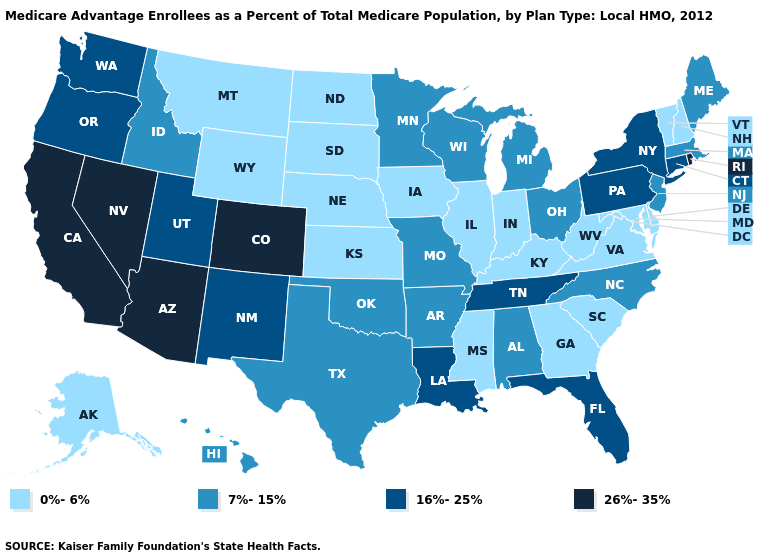What is the value of Maryland?
Be succinct. 0%-6%. What is the value of Nebraska?
Concise answer only. 0%-6%. What is the highest value in the USA?
Write a very short answer. 26%-35%. Name the states that have a value in the range 0%-6%?
Short answer required. Alaska, Delaware, Georgia, Iowa, Illinois, Indiana, Kansas, Kentucky, Maryland, Mississippi, Montana, North Dakota, Nebraska, New Hampshire, South Carolina, South Dakota, Virginia, Vermont, West Virginia, Wyoming. What is the lowest value in the USA?
Give a very brief answer. 0%-6%. Is the legend a continuous bar?
Be succinct. No. Name the states that have a value in the range 7%-15%?
Be succinct. Alabama, Arkansas, Hawaii, Idaho, Massachusetts, Maine, Michigan, Minnesota, Missouri, North Carolina, New Jersey, Ohio, Oklahoma, Texas, Wisconsin. Does the map have missing data?
Be succinct. No. Does the first symbol in the legend represent the smallest category?
Give a very brief answer. Yes. Name the states that have a value in the range 16%-25%?
Concise answer only. Connecticut, Florida, Louisiana, New Mexico, New York, Oregon, Pennsylvania, Tennessee, Utah, Washington. What is the highest value in the MidWest ?
Write a very short answer. 7%-15%. Name the states that have a value in the range 0%-6%?
Write a very short answer. Alaska, Delaware, Georgia, Iowa, Illinois, Indiana, Kansas, Kentucky, Maryland, Mississippi, Montana, North Dakota, Nebraska, New Hampshire, South Carolina, South Dakota, Virginia, Vermont, West Virginia, Wyoming. What is the value of Colorado?
Concise answer only. 26%-35%. Among the states that border Oklahoma , which have the lowest value?
Concise answer only. Kansas. Does Alabama have the lowest value in the USA?
Give a very brief answer. No. 